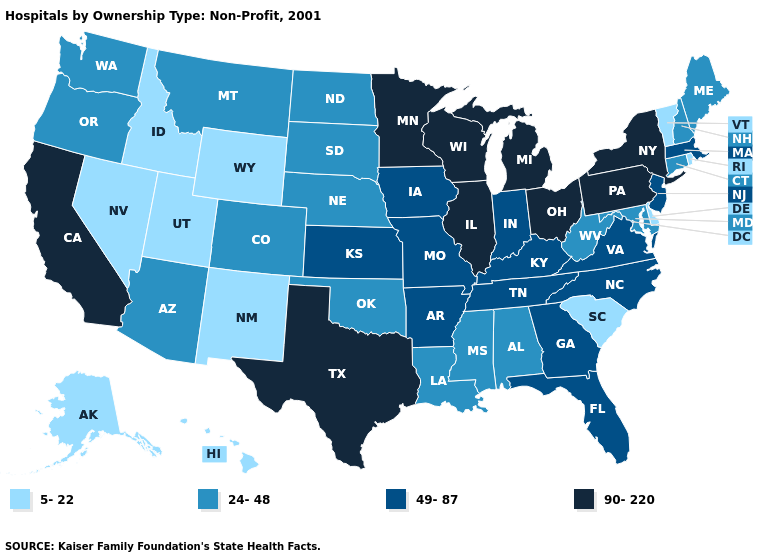What is the highest value in the West ?
Quick response, please. 90-220. Among the states that border New York , which have the lowest value?
Answer briefly. Vermont. Name the states that have a value in the range 90-220?
Be succinct. California, Illinois, Michigan, Minnesota, New York, Ohio, Pennsylvania, Texas, Wisconsin. Name the states that have a value in the range 5-22?
Concise answer only. Alaska, Delaware, Hawaii, Idaho, Nevada, New Mexico, Rhode Island, South Carolina, Utah, Vermont, Wyoming. Among the states that border Idaho , which have the lowest value?
Be succinct. Nevada, Utah, Wyoming. Name the states that have a value in the range 24-48?
Answer briefly. Alabama, Arizona, Colorado, Connecticut, Louisiana, Maine, Maryland, Mississippi, Montana, Nebraska, New Hampshire, North Dakota, Oklahoma, Oregon, South Dakota, Washington, West Virginia. Does Florida have the highest value in the South?
Keep it brief. No. What is the lowest value in the USA?
Write a very short answer. 5-22. Which states have the lowest value in the USA?
Give a very brief answer. Alaska, Delaware, Hawaii, Idaho, Nevada, New Mexico, Rhode Island, South Carolina, Utah, Vermont, Wyoming. What is the value of North Carolina?
Give a very brief answer. 49-87. Does Alabama have the highest value in the USA?
Give a very brief answer. No. What is the lowest value in the South?
Quick response, please. 5-22. What is the value of Florida?
Answer briefly. 49-87. How many symbols are there in the legend?
Write a very short answer. 4. 